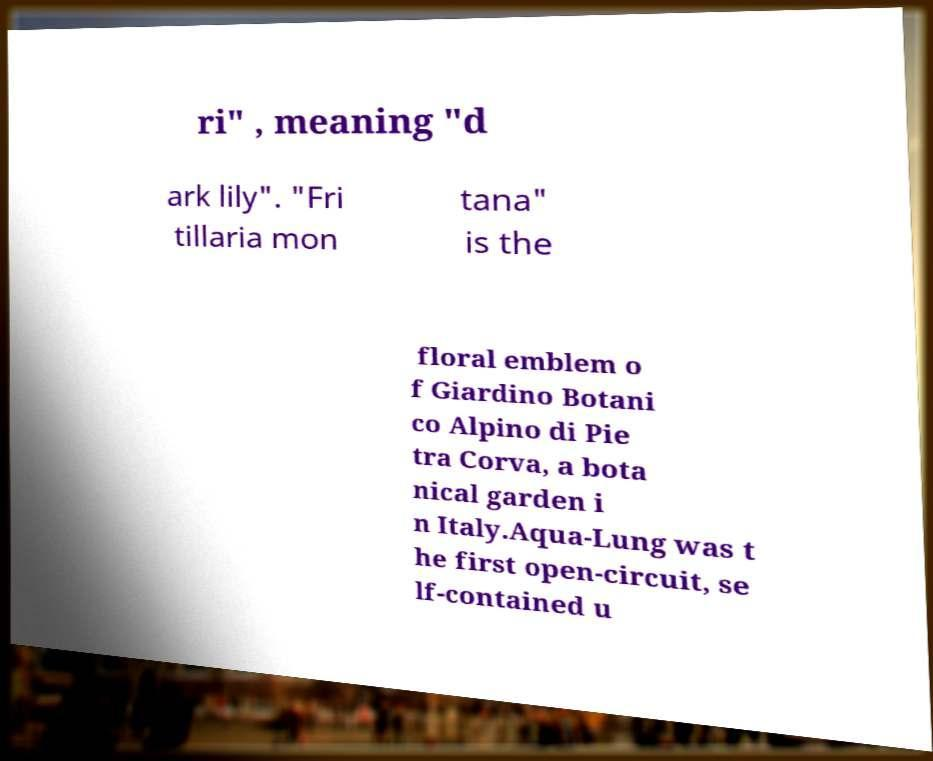Can you read and provide the text displayed in the image?This photo seems to have some interesting text. Can you extract and type it out for me? ri" , meaning "d ark lily". "Fri tillaria mon tana" is the floral emblem o f Giardino Botani co Alpino di Pie tra Corva, a bota nical garden i n Italy.Aqua-Lung was t he first open-circuit, se lf-contained u 